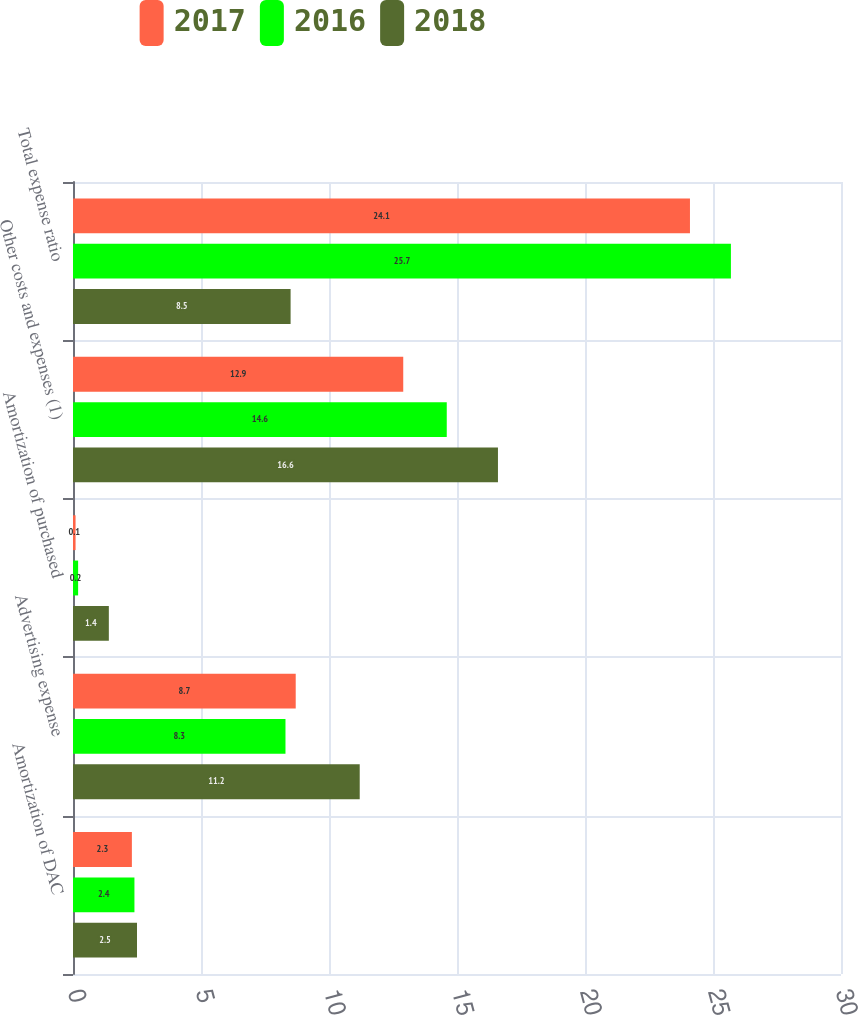Convert chart. <chart><loc_0><loc_0><loc_500><loc_500><stacked_bar_chart><ecel><fcel>Amortization of DAC<fcel>Advertising expense<fcel>Amortization of purchased<fcel>Other costs and expenses (1)<fcel>Total expense ratio<nl><fcel>2017<fcel>2.3<fcel>8.7<fcel>0.1<fcel>12.9<fcel>24.1<nl><fcel>2016<fcel>2.4<fcel>8.3<fcel>0.2<fcel>14.6<fcel>25.7<nl><fcel>2018<fcel>2.5<fcel>11.2<fcel>1.4<fcel>16.6<fcel>8.5<nl></chart> 